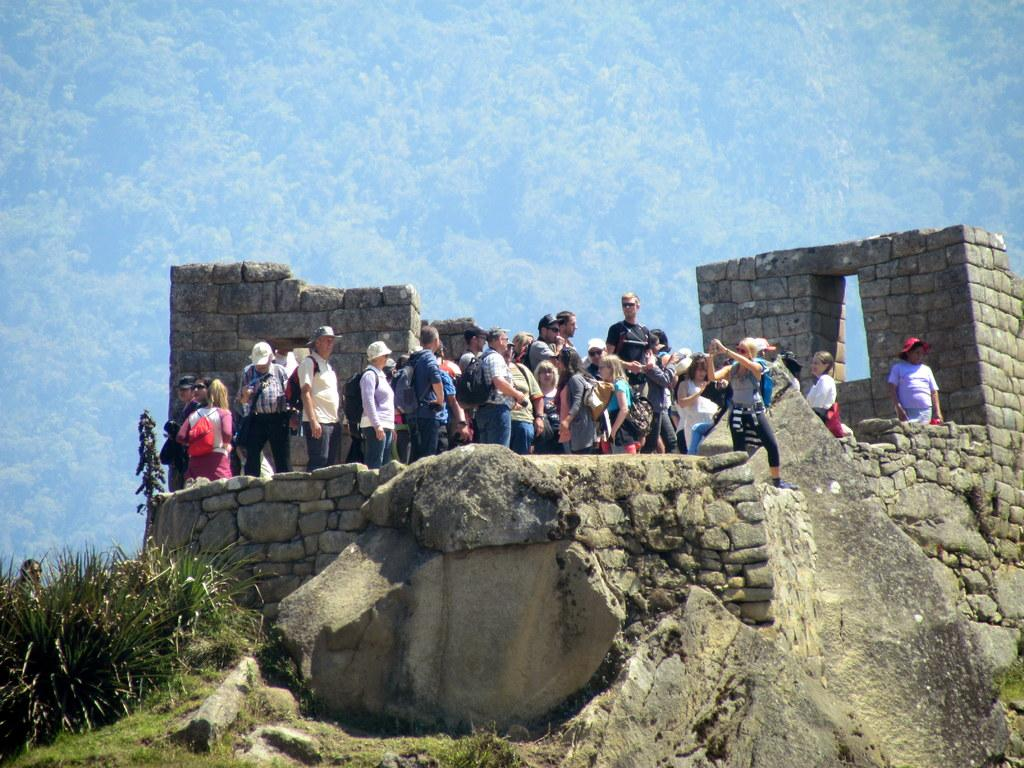What is the main feature in the center of the image? There is an outcrop in the center of the image. What is happening on the outcrop? There is a group of people on the outcrop. What can be seen in the bottom left side of the image? There are plants in the bottom left side of the image. Can you see a railway or an airplane in the image? No, there is no railway or airplane present in the image. Is there a van parked near the outcrop? No, there is no van mentioned or visible in the image. 